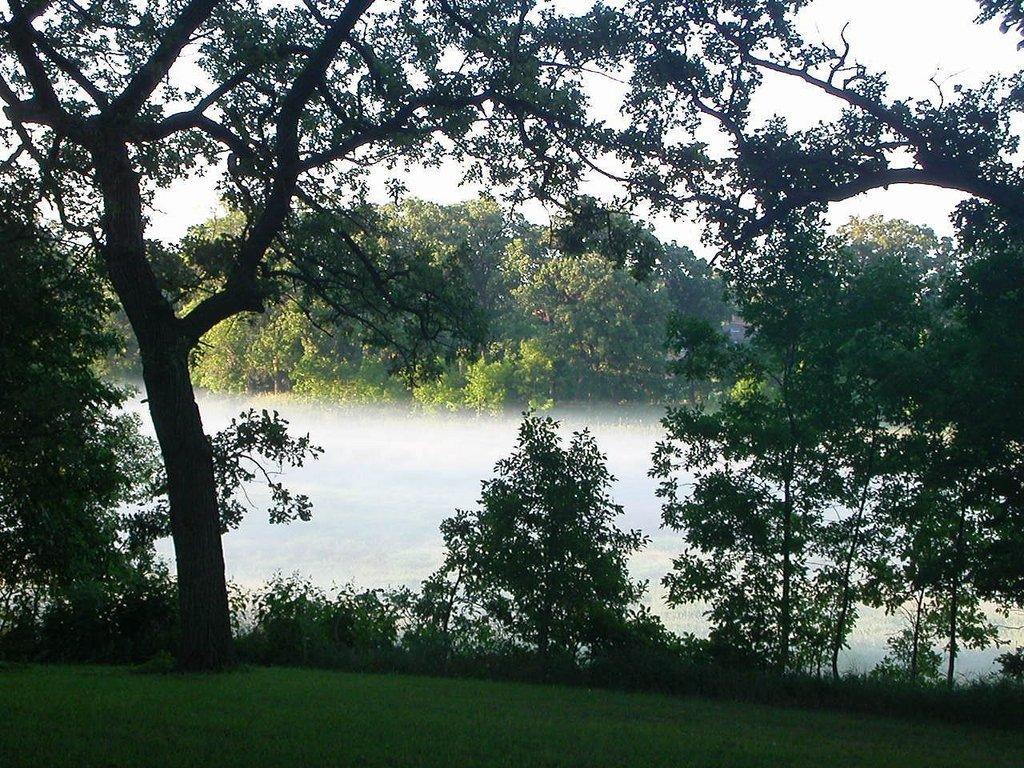In one or two sentences, can you explain what this image depicts? This picture is clicked outside. In the foreground we can see the green grass, plants and trees. In the center we can see the smoke and in the background we can see the sky, trees and plants and some other objects. 